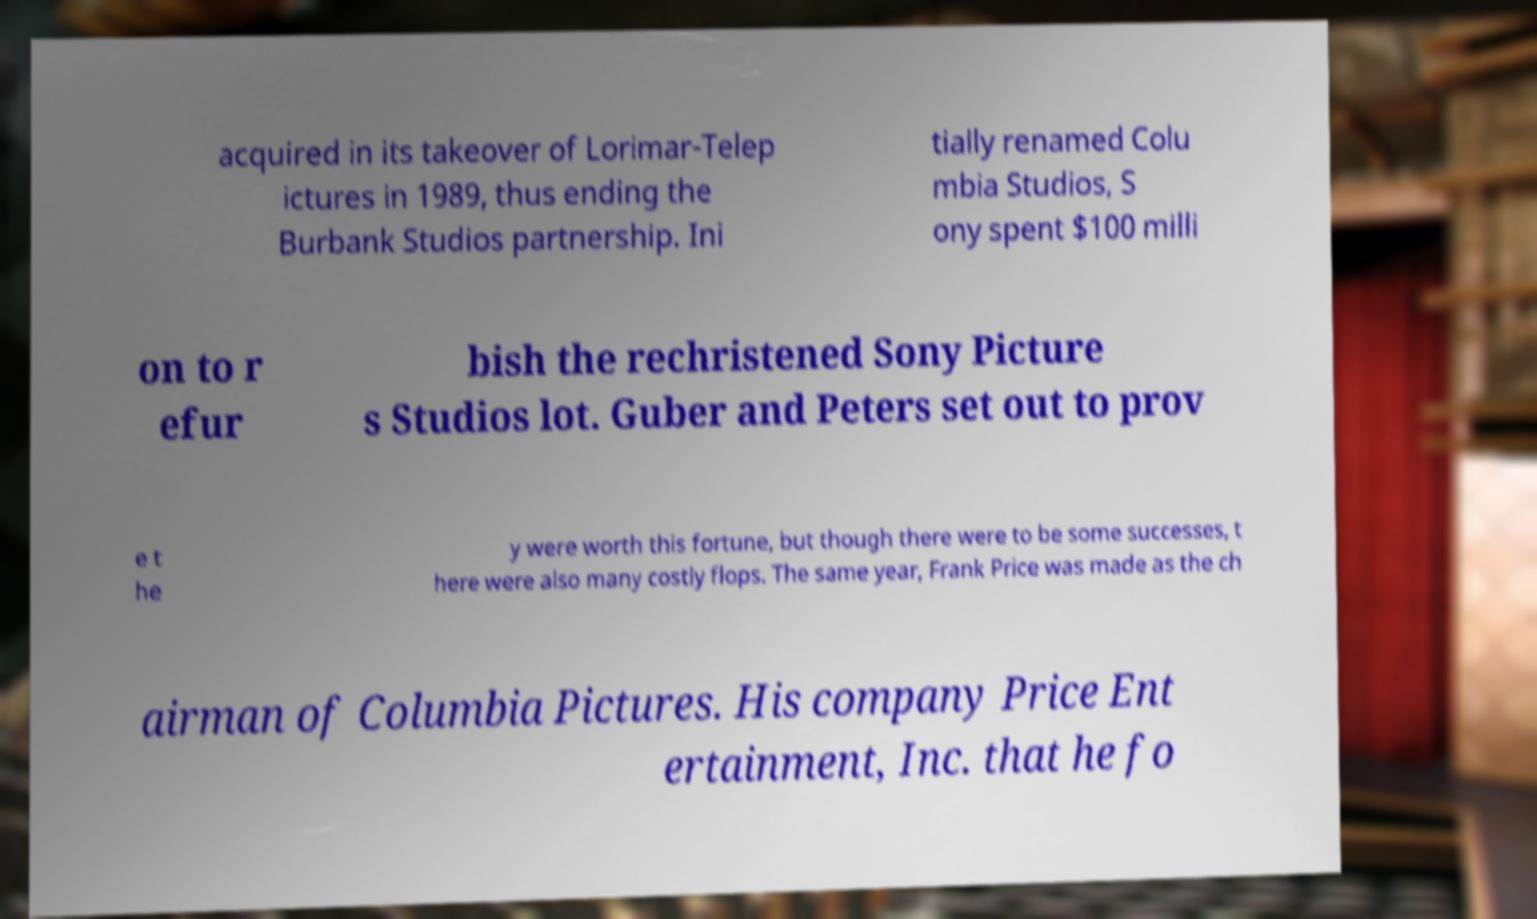Could you assist in decoding the text presented in this image and type it out clearly? acquired in its takeover of Lorimar-Telep ictures in 1989, thus ending the Burbank Studios partnership. Ini tially renamed Colu mbia Studios, S ony spent $100 milli on to r efur bish the rechristened Sony Picture s Studios lot. Guber and Peters set out to prov e t he y were worth this fortune, but though there were to be some successes, t here were also many costly flops. The same year, Frank Price was made as the ch airman of Columbia Pictures. His company Price Ent ertainment, Inc. that he fo 